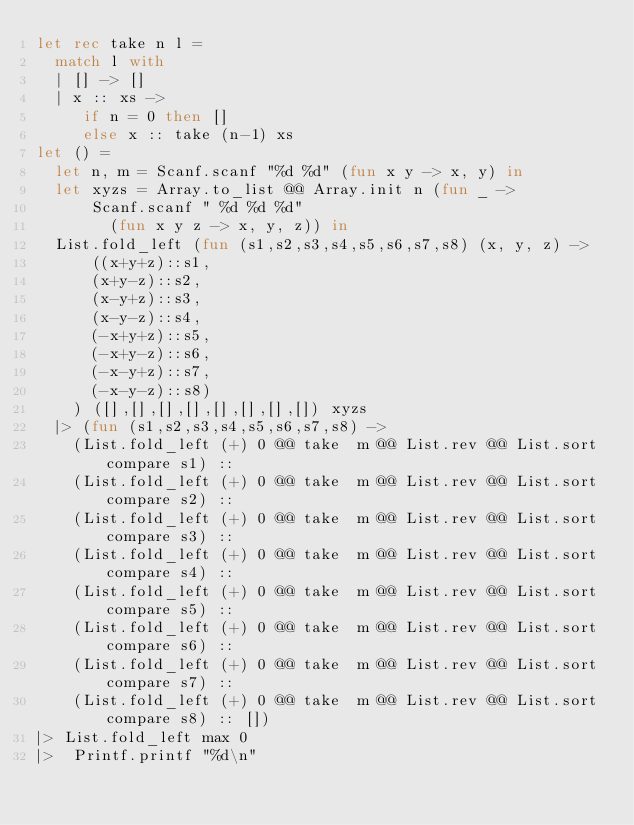Convert code to text. <code><loc_0><loc_0><loc_500><loc_500><_OCaml_>let rec take n l =
  match l with
  | [] -> []
  | x :: xs ->
     if n = 0 then []
     else x :: take (n-1) xs
let () =
  let n, m = Scanf.scanf "%d %d" (fun x y -> x, y) in
  let xyzs = Array.to_list @@ Array.init n (fun _ ->
      Scanf.scanf " %d %d %d"
        (fun x y z -> x, y, z)) in
  List.fold_left (fun (s1,s2,s3,s4,s5,s6,s7,s8) (x, y, z) ->
      ((x+y+z)::s1,
      (x+y-z)::s2,
      (x-y+z)::s3,
      (x-y-z)::s4,
      (-x+y+z)::s5,
      (-x+y-z)::s6,
      (-x-y+z)::s7,
      (-x-y-z)::s8)
    ) ([],[],[],[],[],[],[],[]) xyzs
  |> (fun (s1,s2,s3,s4,s5,s6,s7,s8) ->
    (List.fold_left (+) 0 @@ take  m @@ List.rev @@ List.sort compare s1) ::
    (List.fold_left (+) 0 @@ take  m @@ List.rev @@ List.sort compare s2) ::
    (List.fold_left (+) 0 @@ take  m @@ List.rev @@ List.sort compare s3) ::
    (List.fold_left (+) 0 @@ take  m @@ List.rev @@ List.sort compare s4) ::
    (List.fold_left (+) 0 @@ take  m @@ List.rev @@ List.sort compare s5) ::
    (List.fold_left (+) 0 @@ take  m @@ List.rev @@ List.sort compare s6) ::
    (List.fold_left (+) 0 @@ take  m @@ List.rev @@ List.sort compare s7) ::
    (List.fold_left (+) 0 @@ take  m @@ List.rev @@ List.sort compare s8) :: [])
|> List.fold_left max 0  
|>  Printf.printf "%d\n"
</code> 